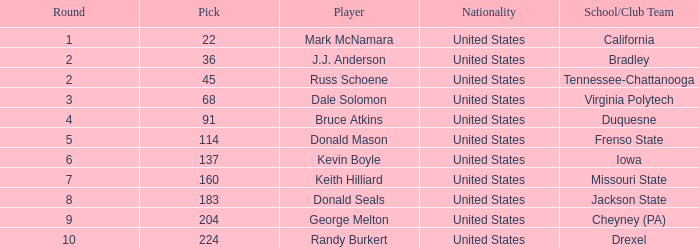From which country does the drexel athlete with a pick number exceeding 183 come? United States. 